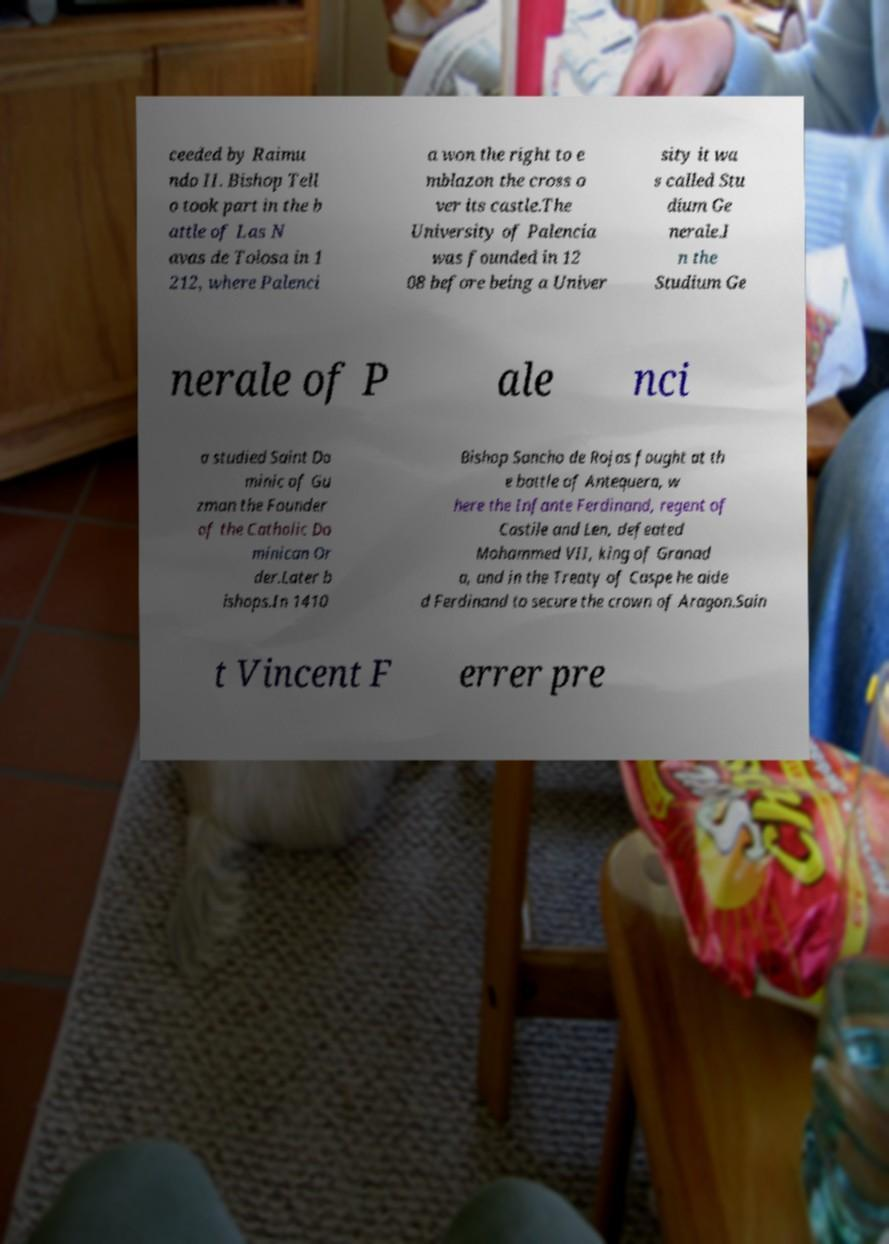Could you extract and type out the text from this image? ceeded by Raimu ndo II. Bishop Tell o took part in the b attle of Las N avas de Tolosa in 1 212, where Palenci a won the right to e mblazon the cross o ver its castle.The University of Palencia was founded in 12 08 before being a Univer sity it wa s called Stu dium Ge nerale.I n the Studium Ge nerale of P ale nci a studied Saint Do minic of Gu zman the Founder of the Catholic Do minican Or der.Later b ishops.In 1410 Bishop Sancho de Rojas fought at th e battle of Antequera, w here the Infante Ferdinand, regent of Castile and Len, defeated Mohammed VII, king of Granad a, and in the Treaty of Caspe he aide d Ferdinand to secure the crown of Aragon.Sain t Vincent F errer pre 